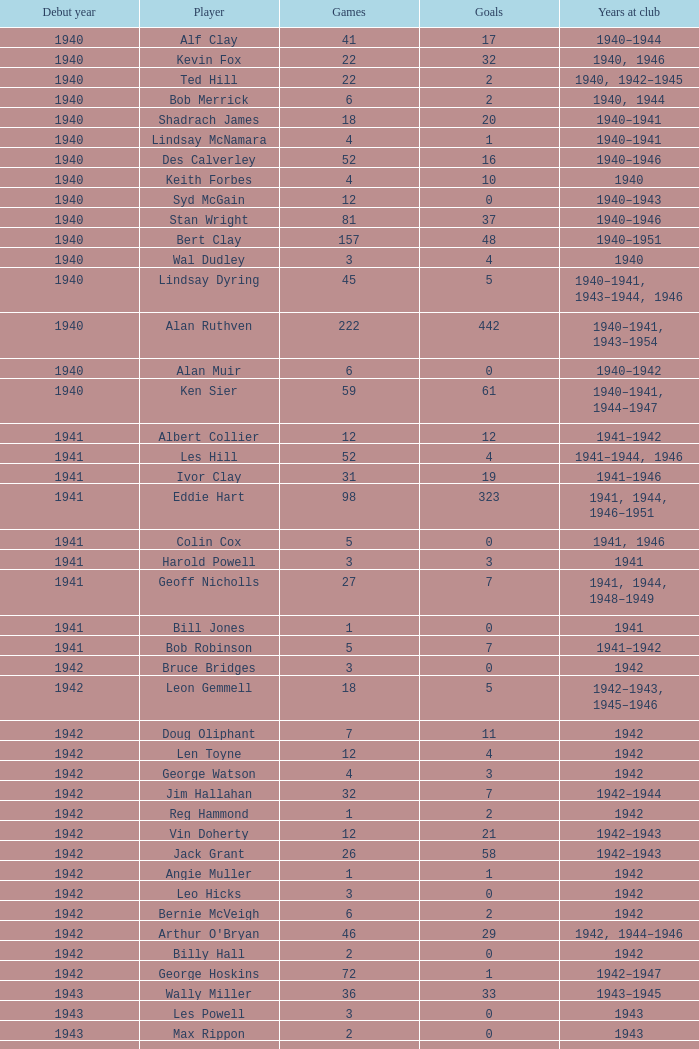Can you give me this table as a dict? {'header': ['Debut year', 'Player', 'Games', 'Goals', 'Years at club'], 'rows': [['1940', 'Alf Clay', '41', '17', '1940–1944'], ['1940', 'Kevin Fox', '22', '32', '1940, 1946'], ['1940', 'Ted Hill', '22', '2', '1940, 1942–1945'], ['1940', 'Bob Merrick', '6', '2', '1940, 1944'], ['1940', 'Shadrach James', '18', '20', '1940–1941'], ['1940', 'Lindsay McNamara', '4', '1', '1940–1941'], ['1940', 'Des Calverley', '52', '16', '1940–1946'], ['1940', 'Keith Forbes', '4', '10', '1940'], ['1940', 'Syd McGain', '12', '0', '1940–1943'], ['1940', 'Stan Wright', '81', '37', '1940–1946'], ['1940', 'Bert Clay', '157', '48', '1940–1951'], ['1940', 'Wal Dudley', '3', '4', '1940'], ['1940', 'Lindsay Dyring', '45', '5', '1940–1941, 1943–1944, 1946'], ['1940', 'Alan Ruthven', '222', '442', '1940–1941, 1943–1954'], ['1940', 'Alan Muir', '6', '0', '1940–1942'], ['1940', 'Ken Sier', '59', '61', '1940–1941, 1944–1947'], ['1941', 'Albert Collier', '12', '12', '1941–1942'], ['1941', 'Les Hill', '52', '4', '1941–1944, 1946'], ['1941', 'Ivor Clay', '31', '19', '1941–1946'], ['1941', 'Eddie Hart', '98', '323', '1941, 1944, 1946–1951'], ['1941', 'Colin Cox', '5', '0', '1941, 1946'], ['1941', 'Harold Powell', '3', '3', '1941'], ['1941', 'Geoff Nicholls', '27', '7', '1941, 1944, 1948–1949'], ['1941', 'Bill Jones', '1', '0', '1941'], ['1941', 'Bob Robinson', '5', '7', '1941–1942'], ['1942', 'Bruce Bridges', '3', '0', '1942'], ['1942', 'Leon Gemmell', '18', '5', '1942–1943, 1945–1946'], ['1942', 'Doug Oliphant', '7', '11', '1942'], ['1942', 'Len Toyne', '12', '4', '1942'], ['1942', 'George Watson', '4', '3', '1942'], ['1942', 'Jim Hallahan', '32', '7', '1942–1944'], ['1942', 'Reg Hammond', '1', '2', '1942'], ['1942', 'Vin Doherty', '12', '21', '1942–1943'], ['1942', 'Jack Grant', '26', '58', '1942–1943'], ['1942', 'Angie Muller', '1', '1', '1942'], ['1942', 'Leo Hicks', '3', '0', '1942'], ['1942', 'Bernie McVeigh', '6', '2', '1942'], ['1942', "Arthur O'Bryan", '46', '29', '1942, 1944–1946'], ['1942', 'Billy Hall', '2', '0', '1942'], ['1942', 'George Hoskins', '72', '1', '1942–1947'], ['1943', 'Wally Miller', '36', '33', '1943–1945'], ['1943', 'Les Powell', '3', '0', '1943'], ['1943', 'Max Rippon', '2', '0', '1943'], ['1943', 'Stan Dawson', '57', '40', '1943–1946'], ['1943', 'Harold Winberg', '32', '12', '1943, 1945–1946'], ['1943', 'Merv Brooks', '2', '0', '1943–1944'], ['1943', 'Doug Brown', '13', '21', '1943'], ['1943', 'Ralph Patman', '1', '0', '1943'], ['1943', 'Jack Lancaster', '9', '6', '1943–1944'], ['1943', 'Bob McHenry', '5', '2', '1943'], ['1943', 'Ted Tomkins', '1', '0', '1943'], ['1943', 'Bernie Fyffe', '2', '3', '1943'], ['1943', 'Monty Horan', '21', '1', '1943–1946'], ['1943', 'Adrian Hearn', '3', '1', '1943'], ['1943', 'Dennis Hall', '5', '0', '1943–1945'], ['1943', 'Bill Spokes', '5', '3', '1943–1944'], ['1944', 'Billy Walsh', '1', '0', '1944'], ['1944', 'Wally Bristowe', '18', '14', '1944–1945'], ['1944', 'Laurie Bickerton', '12', '0', '1944'], ['1944', 'Charlie Linney', '12', '0', '1944–1946'], ['1944', 'Jack Harrow', '2', '0', '1944'], ['1944', 'Noel Jarvis', '159', '31', '1944–1952'], ['1944', 'Norm Johnstone', '228', '185', '1944–1957'], ['1944', 'Jack Symons', '36', '58', '1944–1946'], ['1945', 'Laurie Crouch', '8', '4', '1945–1946'], ['1945', 'Jack Collins', '31', '36', '1945–1949'], ['1945', 'Jim Kettle', '41', '23', '1945, 1947–1952'], ['1945', 'Peter Dalwood', '7', '12', '1945'], ['1945', 'Ed White', '1', '0', '1945'], ['1945', 'Don Hammond', '5', '0', '1945'], ['1945', 'Harold Shillinglaw', '63', '19', '1945–1951'], ['1945', 'Jim Brown', '10', '5', '1945, 1947'], ['1946', 'Alan McLaughlin', '76', '6', '1946–1950'], ['1946', 'Merv Smith', '9', '0', '1946–1948'], ['1946', 'Vic Chanter', '108', '0', '1946–1952'], ['1946', 'Norm Reidy', '1', '0', '1946'], ['1946', 'Reg Nicholls', '83', '3', '1946–1950'], ['1946', 'Bob Miller', '44', '3', '1946–1950'], ['1946', 'Stan Vandersluys', '47', '26', '1946–1952'], ['1946', 'Allan Broadway', '3', '2', '1946'], ['1947', 'Bill Stephen', '162', '4', '1947–1957'], ['1947', 'Don Chipp', '3', '1', '1947'], ['1947', 'George Coates', '128', '128', '1947–1954'], ['1947', 'Heinz Tonn', '6', '2', '1947'], ['1947', 'Dick Kennedy', '63', '47', '1947–1951'], ['1947', "Neil O'Reilly", '1', '0', '1947'], ['1947', 'Jim Toohey', '57', '12', '1947–1949, 1951–1952'], ['1947', 'Llew Owens', '5', '3', '1947'], ['1947', 'Kevin Hart', '19', '8', '1947–1949'], ['1948', 'Ron Kinder', '5', '1', '1948'], ['1948', 'Ken Ross', '129', '36', '1948–1955, 1959–1960'], ['1948', 'Keith Williams', '18', '12', '1948'], ['1948', 'Wal Alexander', '7', '0', '1948'], ['1948', 'Eric Moore', '19', '14', '1948–1950'], ['1948', 'Gerry Sier', '10', '0', '1948–1949'], ['1948', 'Gordon Brunnen', '3', '0', '1948'], ['1948', 'Bill Charleson', '4', '0', '1948'], ['1948', 'Alan Gale', '213', '19', '1948–1961'], ['1949', 'Jack Gaffney', '80', '0', '1949–1953'], ['1949', 'Ron Simpson', '37', '23', '1949–1953'], ['1949', 'Norm Smith', '17', '26', '1949–1950'], ['1949', 'Barry Waters', '1', '0', '1949'], ['1949', 'Ray Donnellan', '40', '0', '1949–1951'], ['1949', 'Jack Streader', '69', '45', '1949–1955'], ['1949', 'Don Furness', '136', '43', '1949–1959'], ['1949', 'Eddie Goodger', '149', '1', '1949–1958'], ['1949', 'Ron Bickley', '29', '0', '1949–1951'], ['1949', 'Ron Wright', '3', '0', '1949'], ['1949', 'Reg Milburn', '2', '0', '1949']]} Which player debuted before 1943, played for the club in 1942, played less than 12 games, and scored less than 11 goals? Bruce Bridges, George Watson, Reg Hammond, Angie Muller, Leo Hicks, Bernie McVeigh, Billy Hall. 